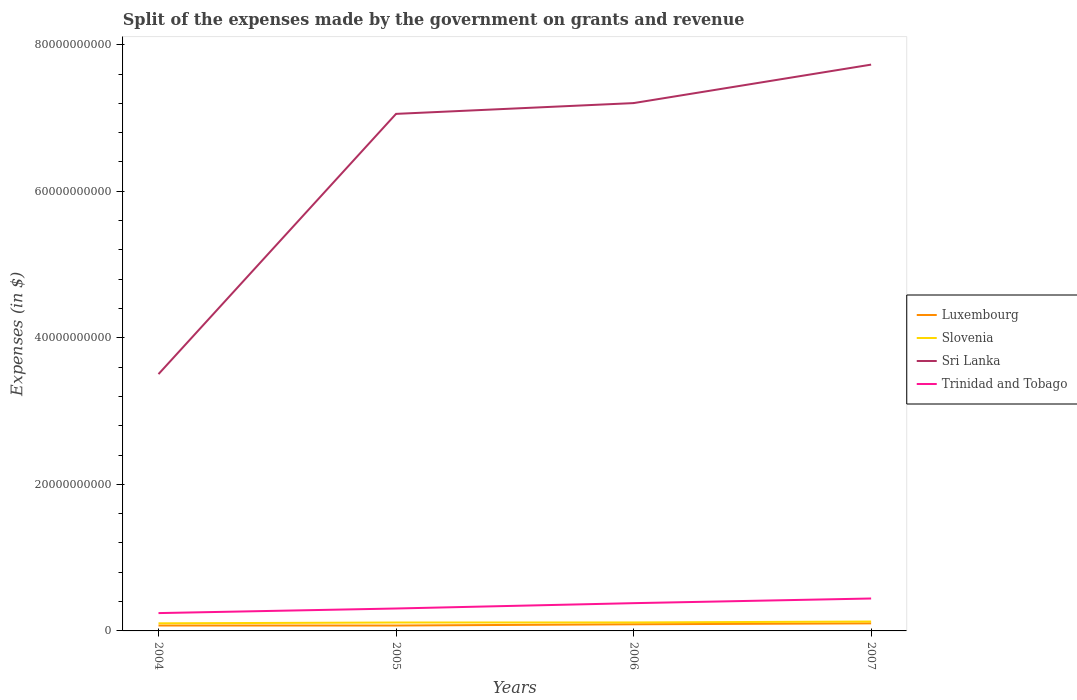Across all years, what is the maximum expenses made by the government on grants and revenue in Luxembourg?
Provide a short and direct response. 7.36e+08. What is the total expenses made by the government on grants and revenue in Luxembourg in the graph?
Give a very brief answer. -1.26e+08. What is the difference between the highest and the second highest expenses made by the government on grants and revenue in Slovenia?
Provide a succinct answer. 2.45e+08. What is the difference between the highest and the lowest expenses made by the government on grants and revenue in Luxembourg?
Offer a terse response. 2. Is the expenses made by the government on grants and revenue in Sri Lanka strictly greater than the expenses made by the government on grants and revenue in Luxembourg over the years?
Make the answer very short. No. What is the difference between two consecutive major ticks on the Y-axis?
Offer a terse response. 2.00e+1. Are the values on the major ticks of Y-axis written in scientific E-notation?
Ensure brevity in your answer.  No. Where does the legend appear in the graph?
Ensure brevity in your answer.  Center right. What is the title of the graph?
Your answer should be compact. Split of the expenses made by the government on grants and revenue. Does "St. Kitts and Nevis" appear as one of the legend labels in the graph?
Ensure brevity in your answer.  No. What is the label or title of the X-axis?
Provide a short and direct response. Years. What is the label or title of the Y-axis?
Provide a succinct answer. Expenses (in $). What is the Expenses (in $) of Luxembourg in 2004?
Give a very brief answer. 7.38e+08. What is the Expenses (in $) of Slovenia in 2004?
Offer a terse response. 1.04e+09. What is the Expenses (in $) of Sri Lanka in 2004?
Offer a very short reply. 3.51e+1. What is the Expenses (in $) in Trinidad and Tobago in 2004?
Give a very brief answer. 2.43e+09. What is the Expenses (in $) in Luxembourg in 2005?
Keep it short and to the point. 7.36e+08. What is the Expenses (in $) of Slovenia in 2005?
Offer a very short reply. 1.15e+09. What is the Expenses (in $) of Sri Lanka in 2005?
Ensure brevity in your answer.  7.06e+1. What is the Expenses (in $) in Trinidad and Tobago in 2005?
Your response must be concise. 3.06e+09. What is the Expenses (in $) in Luxembourg in 2006?
Make the answer very short. 9.05e+08. What is the Expenses (in $) in Slovenia in 2006?
Your answer should be very brief. 1.16e+09. What is the Expenses (in $) of Sri Lanka in 2006?
Your answer should be compact. 7.20e+1. What is the Expenses (in $) of Trinidad and Tobago in 2006?
Your response must be concise. 3.79e+09. What is the Expenses (in $) in Luxembourg in 2007?
Ensure brevity in your answer.  1.03e+09. What is the Expenses (in $) in Slovenia in 2007?
Your answer should be compact. 1.28e+09. What is the Expenses (in $) in Sri Lanka in 2007?
Offer a terse response. 7.73e+1. What is the Expenses (in $) of Trinidad and Tobago in 2007?
Ensure brevity in your answer.  4.42e+09. Across all years, what is the maximum Expenses (in $) in Luxembourg?
Make the answer very short. 1.03e+09. Across all years, what is the maximum Expenses (in $) of Slovenia?
Offer a terse response. 1.28e+09. Across all years, what is the maximum Expenses (in $) in Sri Lanka?
Give a very brief answer. 7.73e+1. Across all years, what is the maximum Expenses (in $) in Trinidad and Tobago?
Keep it short and to the point. 4.42e+09. Across all years, what is the minimum Expenses (in $) in Luxembourg?
Offer a very short reply. 7.36e+08. Across all years, what is the minimum Expenses (in $) in Slovenia?
Offer a very short reply. 1.04e+09. Across all years, what is the minimum Expenses (in $) in Sri Lanka?
Provide a short and direct response. 3.51e+1. Across all years, what is the minimum Expenses (in $) in Trinidad and Tobago?
Offer a terse response. 2.43e+09. What is the total Expenses (in $) in Luxembourg in the graph?
Your answer should be very brief. 3.41e+09. What is the total Expenses (in $) in Slovenia in the graph?
Your answer should be compact. 4.63e+09. What is the total Expenses (in $) of Sri Lanka in the graph?
Offer a very short reply. 2.55e+11. What is the total Expenses (in $) in Trinidad and Tobago in the graph?
Your answer should be very brief. 1.37e+1. What is the difference between the Expenses (in $) in Luxembourg in 2004 and that in 2005?
Ensure brevity in your answer.  1.85e+06. What is the difference between the Expenses (in $) in Slovenia in 2004 and that in 2005?
Provide a succinct answer. -1.10e+08. What is the difference between the Expenses (in $) of Sri Lanka in 2004 and that in 2005?
Offer a very short reply. -3.55e+1. What is the difference between the Expenses (in $) in Trinidad and Tobago in 2004 and that in 2005?
Your response must be concise. -6.26e+08. What is the difference between the Expenses (in $) in Luxembourg in 2004 and that in 2006?
Make the answer very short. -1.67e+08. What is the difference between the Expenses (in $) in Slovenia in 2004 and that in 2006?
Your answer should be compact. -1.20e+08. What is the difference between the Expenses (in $) in Sri Lanka in 2004 and that in 2006?
Your answer should be compact. -3.70e+1. What is the difference between the Expenses (in $) in Trinidad and Tobago in 2004 and that in 2006?
Give a very brief answer. -1.36e+09. What is the difference between the Expenses (in $) of Luxembourg in 2004 and that in 2007?
Ensure brevity in your answer.  -2.93e+08. What is the difference between the Expenses (in $) of Slovenia in 2004 and that in 2007?
Your answer should be very brief. -2.45e+08. What is the difference between the Expenses (in $) of Sri Lanka in 2004 and that in 2007?
Offer a terse response. -4.22e+1. What is the difference between the Expenses (in $) of Trinidad and Tobago in 2004 and that in 2007?
Offer a terse response. -1.99e+09. What is the difference between the Expenses (in $) of Luxembourg in 2005 and that in 2006?
Your answer should be compact. -1.69e+08. What is the difference between the Expenses (in $) of Slovenia in 2005 and that in 2006?
Offer a very short reply. -9.36e+06. What is the difference between the Expenses (in $) in Sri Lanka in 2005 and that in 2006?
Provide a succinct answer. -1.47e+09. What is the difference between the Expenses (in $) in Trinidad and Tobago in 2005 and that in 2006?
Your response must be concise. -7.30e+08. What is the difference between the Expenses (in $) in Luxembourg in 2005 and that in 2007?
Provide a succinct answer. -2.95e+08. What is the difference between the Expenses (in $) in Slovenia in 2005 and that in 2007?
Provide a succinct answer. -1.35e+08. What is the difference between the Expenses (in $) of Sri Lanka in 2005 and that in 2007?
Offer a terse response. -6.72e+09. What is the difference between the Expenses (in $) in Trinidad and Tobago in 2005 and that in 2007?
Your response must be concise. -1.36e+09. What is the difference between the Expenses (in $) in Luxembourg in 2006 and that in 2007?
Offer a terse response. -1.26e+08. What is the difference between the Expenses (in $) of Slovenia in 2006 and that in 2007?
Make the answer very short. -1.25e+08. What is the difference between the Expenses (in $) of Sri Lanka in 2006 and that in 2007?
Offer a very short reply. -5.25e+09. What is the difference between the Expenses (in $) of Trinidad and Tobago in 2006 and that in 2007?
Provide a succinct answer. -6.34e+08. What is the difference between the Expenses (in $) of Luxembourg in 2004 and the Expenses (in $) of Slovenia in 2005?
Give a very brief answer. -4.10e+08. What is the difference between the Expenses (in $) in Luxembourg in 2004 and the Expenses (in $) in Sri Lanka in 2005?
Provide a short and direct response. -6.98e+1. What is the difference between the Expenses (in $) of Luxembourg in 2004 and the Expenses (in $) of Trinidad and Tobago in 2005?
Make the answer very short. -2.32e+09. What is the difference between the Expenses (in $) in Slovenia in 2004 and the Expenses (in $) in Sri Lanka in 2005?
Give a very brief answer. -6.95e+1. What is the difference between the Expenses (in $) in Slovenia in 2004 and the Expenses (in $) in Trinidad and Tobago in 2005?
Your response must be concise. -2.02e+09. What is the difference between the Expenses (in $) of Sri Lanka in 2004 and the Expenses (in $) of Trinidad and Tobago in 2005?
Keep it short and to the point. 3.20e+1. What is the difference between the Expenses (in $) in Luxembourg in 2004 and the Expenses (in $) in Slovenia in 2006?
Provide a short and direct response. -4.20e+08. What is the difference between the Expenses (in $) of Luxembourg in 2004 and the Expenses (in $) of Sri Lanka in 2006?
Your answer should be compact. -7.13e+1. What is the difference between the Expenses (in $) in Luxembourg in 2004 and the Expenses (in $) in Trinidad and Tobago in 2006?
Your answer should be compact. -3.05e+09. What is the difference between the Expenses (in $) of Slovenia in 2004 and the Expenses (in $) of Sri Lanka in 2006?
Ensure brevity in your answer.  -7.10e+1. What is the difference between the Expenses (in $) in Slovenia in 2004 and the Expenses (in $) in Trinidad and Tobago in 2006?
Your answer should be compact. -2.75e+09. What is the difference between the Expenses (in $) of Sri Lanka in 2004 and the Expenses (in $) of Trinidad and Tobago in 2006?
Your answer should be compact. 3.13e+1. What is the difference between the Expenses (in $) of Luxembourg in 2004 and the Expenses (in $) of Slovenia in 2007?
Provide a short and direct response. -5.45e+08. What is the difference between the Expenses (in $) in Luxembourg in 2004 and the Expenses (in $) in Sri Lanka in 2007?
Your answer should be very brief. -7.66e+1. What is the difference between the Expenses (in $) of Luxembourg in 2004 and the Expenses (in $) of Trinidad and Tobago in 2007?
Offer a very short reply. -3.69e+09. What is the difference between the Expenses (in $) of Slovenia in 2004 and the Expenses (in $) of Sri Lanka in 2007?
Make the answer very short. -7.63e+1. What is the difference between the Expenses (in $) of Slovenia in 2004 and the Expenses (in $) of Trinidad and Tobago in 2007?
Make the answer very short. -3.39e+09. What is the difference between the Expenses (in $) in Sri Lanka in 2004 and the Expenses (in $) in Trinidad and Tobago in 2007?
Keep it short and to the point. 3.06e+1. What is the difference between the Expenses (in $) of Luxembourg in 2005 and the Expenses (in $) of Slovenia in 2006?
Keep it short and to the point. -4.21e+08. What is the difference between the Expenses (in $) in Luxembourg in 2005 and the Expenses (in $) in Sri Lanka in 2006?
Make the answer very short. -7.13e+1. What is the difference between the Expenses (in $) in Luxembourg in 2005 and the Expenses (in $) in Trinidad and Tobago in 2006?
Provide a short and direct response. -3.05e+09. What is the difference between the Expenses (in $) in Slovenia in 2005 and the Expenses (in $) in Sri Lanka in 2006?
Ensure brevity in your answer.  -7.09e+1. What is the difference between the Expenses (in $) in Slovenia in 2005 and the Expenses (in $) in Trinidad and Tobago in 2006?
Keep it short and to the point. -2.64e+09. What is the difference between the Expenses (in $) in Sri Lanka in 2005 and the Expenses (in $) in Trinidad and Tobago in 2006?
Keep it short and to the point. 6.68e+1. What is the difference between the Expenses (in $) of Luxembourg in 2005 and the Expenses (in $) of Slovenia in 2007?
Your answer should be very brief. -5.47e+08. What is the difference between the Expenses (in $) in Luxembourg in 2005 and the Expenses (in $) in Sri Lanka in 2007?
Your response must be concise. -7.66e+1. What is the difference between the Expenses (in $) in Luxembourg in 2005 and the Expenses (in $) in Trinidad and Tobago in 2007?
Ensure brevity in your answer.  -3.69e+09. What is the difference between the Expenses (in $) of Slovenia in 2005 and the Expenses (in $) of Sri Lanka in 2007?
Provide a succinct answer. -7.61e+1. What is the difference between the Expenses (in $) of Slovenia in 2005 and the Expenses (in $) of Trinidad and Tobago in 2007?
Your answer should be very brief. -3.28e+09. What is the difference between the Expenses (in $) in Sri Lanka in 2005 and the Expenses (in $) in Trinidad and Tobago in 2007?
Your answer should be compact. 6.61e+1. What is the difference between the Expenses (in $) of Luxembourg in 2006 and the Expenses (in $) of Slovenia in 2007?
Your response must be concise. -3.77e+08. What is the difference between the Expenses (in $) in Luxembourg in 2006 and the Expenses (in $) in Sri Lanka in 2007?
Make the answer very short. -7.64e+1. What is the difference between the Expenses (in $) in Luxembourg in 2006 and the Expenses (in $) in Trinidad and Tobago in 2007?
Offer a very short reply. -3.52e+09. What is the difference between the Expenses (in $) of Slovenia in 2006 and the Expenses (in $) of Sri Lanka in 2007?
Give a very brief answer. -7.61e+1. What is the difference between the Expenses (in $) of Slovenia in 2006 and the Expenses (in $) of Trinidad and Tobago in 2007?
Keep it short and to the point. -3.27e+09. What is the difference between the Expenses (in $) in Sri Lanka in 2006 and the Expenses (in $) in Trinidad and Tobago in 2007?
Your answer should be very brief. 6.76e+1. What is the average Expenses (in $) of Luxembourg per year?
Your response must be concise. 8.53e+08. What is the average Expenses (in $) of Slovenia per year?
Provide a short and direct response. 1.16e+09. What is the average Expenses (in $) in Sri Lanka per year?
Your answer should be very brief. 6.37e+1. What is the average Expenses (in $) in Trinidad and Tobago per year?
Your answer should be very brief. 3.43e+09. In the year 2004, what is the difference between the Expenses (in $) of Luxembourg and Expenses (in $) of Slovenia?
Give a very brief answer. -3.00e+08. In the year 2004, what is the difference between the Expenses (in $) in Luxembourg and Expenses (in $) in Sri Lanka?
Offer a very short reply. -3.43e+1. In the year 2004, what is the difference between the Expenses (in $) of Luxembourg and Expenses (in $) of Trinidad and Tobago?
Provide a succinct answer. -1.70e+09. In the year 2004, what is the difference between the Expenses (in $) of Slovenia and Expenses (in $) of Sri Lanka?
Your answer should be compact. -3.40e+1. In the year 2004, what is the difference between the Expenses (in $) of Slovenia and Expenses (in $) of Trinidad and Tobago?
Your answer should be very brief. -1.40e+09. In the year 2004, what is the difference between the Expenses (in $) in Sri Lanka and Expenses (in $) in Trinidad and Tobago?
Your answer should be very brief. 3.26e+1. In the year 2005, what is the difference between the Expenses (in $) of Luxembourg and Expenses (in $) of Slovenia?
Keep it short and to the point. -4.12e+08. In the year 2005, what is the difference between the Expenses (in $) of Luxembourg and Expenses (in $) of Sri Lanka?
Your response must be concise. -6.98e+1. In the year 2005, what is the difference between the Expenses (in $) in Luxembourg and Expenses (in $) in Trinidad and Tobago?
Provide a succinct answer. -2.32e+09. In the year 2005, what is the difference between the Expenses (in $) in Slovenia and Expenses (in $) in Sri Lanka?
Offer a terse response. -6.94e+1. In the year 2005, what is the difference between the Expenses (in $) in Slovenia and Expenses (in $) in Trinidad and Tobago?
Give a very brief answer. -1.91e+09. In the year 2005, what is the difference between the Expenses (in $) in Sri Lanka and Expenses (in $) in Trinidad and Tobago?
Make the answer very short. 6.75e+1. In the year 2006, what is the difference between the Expenses (in $) of Luxembourg and Expenses (in $) of Slovenia?
Provide a succinct answer. -2.52e+08. In the year 2006, what is the difference between the Expenses (in $) of Luxembourg and Expenses (in $) of Sri Lanka?
Keep it short and to the point. -7.11e+1. In the year 2006, what is the difference between the Expenses (in $) of Luxembourg and Expenses (in $) of Trinidad and Tobago?
Ensure brevity in your answer.  -2.88e+09. In the year 2006, what is the difference between the Expenses (in $) of Slovenia and Expenses (in $) of Sri Lanka?
Make the answer very short. -7.09e+1. In the year 2006, what is the difference between the Expenses (in $) of Slovenia and Expenses (in $) of Trinidad and Tobago?
Your response must be concise. -2.63e+09. In the year 2006, what is the difference between the Expenses (in $) of Sri Lanka and Expenses (in $) of Trinidad and Tobago?
Keep it short and to the point. 6.82e+1. In the year 2007, what is the difference between the Expenses (in $) of Luxembourg and Expenses (in $) of Slovenia?
Your answer should be compact. -2.51e+08. In the year 2007, what is the difference between the Expenses (in $) in Luxembourg and Expenses (in $) in Sri Lanka?
Your response must be concise. -7.63e+1. In the year 2007, what is the difference between the Expenses (in $) in Luxembourg and Expenses (in $) in Trinidad and Tobago?
Offer a terse response. -3.39e+09. In the year 2007, what is the difference between the Expenses (in $) in Slovenia and Expenses (in $) in Sri Lanka?
Keep it short and to the point. -7.60e+1. In the year 2007, what is the difference between the Expenses (in $) of Slovenia and Expenses (in $) of Trinidad and Tobago?
Provide a short and direct response. -3.14e+09. In the year 2007, what is the difference between the Expenses (in $) of Sri Lanka and Expenses (in $) of Trinidad and Tobago?
Provide a short and direct response. 7.29e+1. What is the ratio of the Expenses (in $) in Luxembourg in 2004 to that in 2005?
Give a very brief answer. 1. What is the ratio of the Expenses (in $) in Slovenia in 2004 to that in 2005?
Your answer should be very brief. 0.9. What is the ratio of the Expenses (in $) in Sri Lanka in 2004 to that in 2005?
Your answer should be compact. 0.5. What is the ratio of the Expenses (in $) of Trinidad and Tobago in 2004 to that in 2005?
Provide a succinct answer. 0.8. What is the ratio of the Expenses (in $) of Luxembourg in 2004 to that in 2006?
Offer a terse response. 0.81. What is the ratio of the Expenses (in $) of Slovenia in 2004 to that in 2006?
Give a very brief answer. 0.9. What is the ratio of the Expenses (in $) in Sri Lanka in 2004 to that in 2006?
Provide a succinct answer. 0.49. What is the ratio of the Expenses (in $) of Trinidad and Tobago in 2004 to that in 2006?
Give a very brief answer. 0.64. What is the ratio of the Expenses (in $) of Luxembourg in 2004 to that in 2007?
Your answer should be compact. 0.72. What is the ratio of the Expenses (in $) of Slovenia in 2004 to that in 2007?
Give a very brief answer. 0.81. What is the ratio of the Expenses (in $) of Sri Lanka in 2004 to that in 2007?
Provide a succinct answer. 0.45. What is the ratio of the Expenses (in $) of Trinidad and Tobago in 2004 to that in 2007?
Offer a terse response. 0.55. What is the ratio of the Expenses (in $) in Luxembourg in 2005 to that in 2006?
Your answer should be compact. 0.81. What is the ratio of the Expenses (in $) of Slovenia in 2005 to that in 2006?
Keep it short and to the point. 0.99. What is the ratio of the Expenses (in $) in Sri Lanka in 2005 to that in 2006?
Your answer should be compact. 0.98. What is the ratio of the Expenses (in $) in Trinidad and Tobago in 2005 to that in 2006?
Your answer should be very brief. 0.81. What is the ratio of the Expenses (in $) in Luxembourg in 2005 to that in 2007?
Offer a terse response. 0.71. What is the ratio of the Expenses (in $) in Slovenia in 2005 to that in 2007?
Provide a short and direct response. 0.9. What is the ratio of the Expenses (in $) of Trinidad and Tobago in 2005 to that in 2007?
Your answer should be very brief. 0.69. What is the ratio of the Expenses (in $) in Luxembourg in 2006 to that in 2007?
Ensure brevity in your answer.  0.88. What is the ratio of the Expenses (in $) of Slovenia in 2006 to that in 2007?
Your answer should be compact. 0.9. What is the ratio of the Expenses (in $) of Sri Lanka in 2006 to that in 2007?
Provide a succinct answer. 0.93. What is the ratio of the Expenses (in $) of Trinidad and Tobago in 2006 to that in 2007?
Make the answer very short. 0.86. What is the difference between the highest and the second highest Expenses (in $) of Luxembourg?
Ensure brevity in your answer.  1.26e+08. What is the difference between the highest and the second highest Expenses (in $) of Slovenia?
Ensure brevity in your answer.  1.25e+08. What is the difference between the highest and the second highest Expenses (in $) of Sri Lanka?
Your answer should be compact. 5.25e+09. What is the difference between the highest and the second highest Expenses (in $) in Trinidad and Tobago?
Provide a succinct answer. 6.34e+08. What is the difference between the highest and the lowest Expenses (in $) in Luxembourg?
Provide a short and direct response. 2.95e+08. What is the difference between the highest and the lowest Expenses (in $) of Slovenia?
Your response must be concise. 2.45e+08. What is the difference between the highest and the lowest Expenses (in $) in Sri Lanka?
Provide a short and direct response. 4.22e+1. What is the difference between the highest and the lowest Expenses (in $) of Trinidad and Tobago?
Make the answer very short. 1.99e+09. 